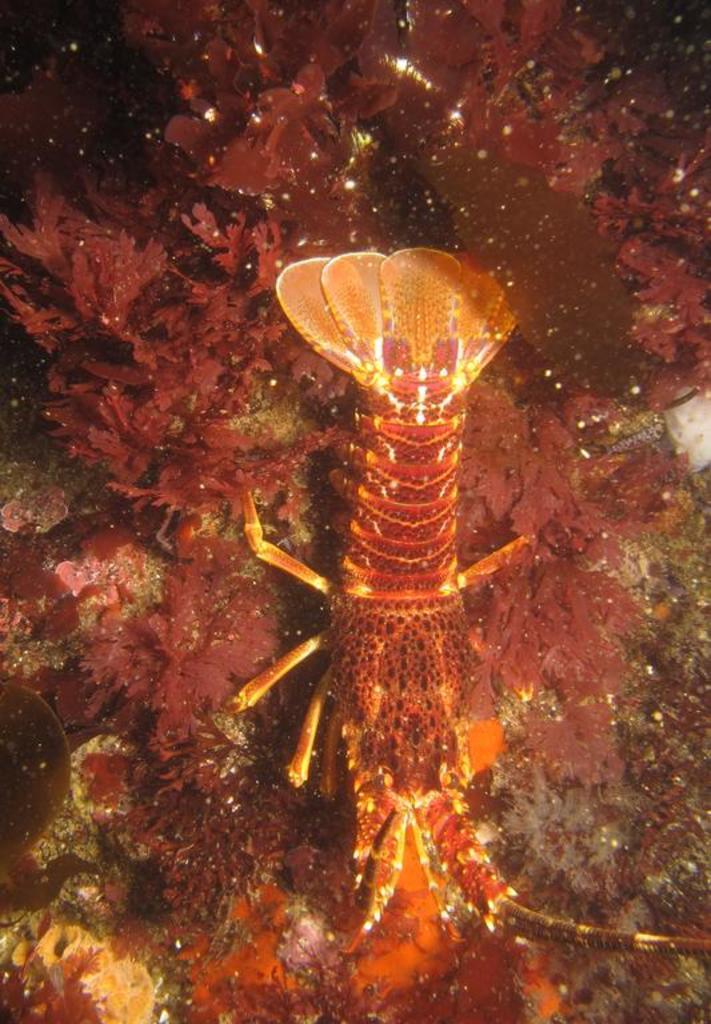Could you give a brief overview of what you see in this image? In the picture I can see a reptile and there are small plants around it. 